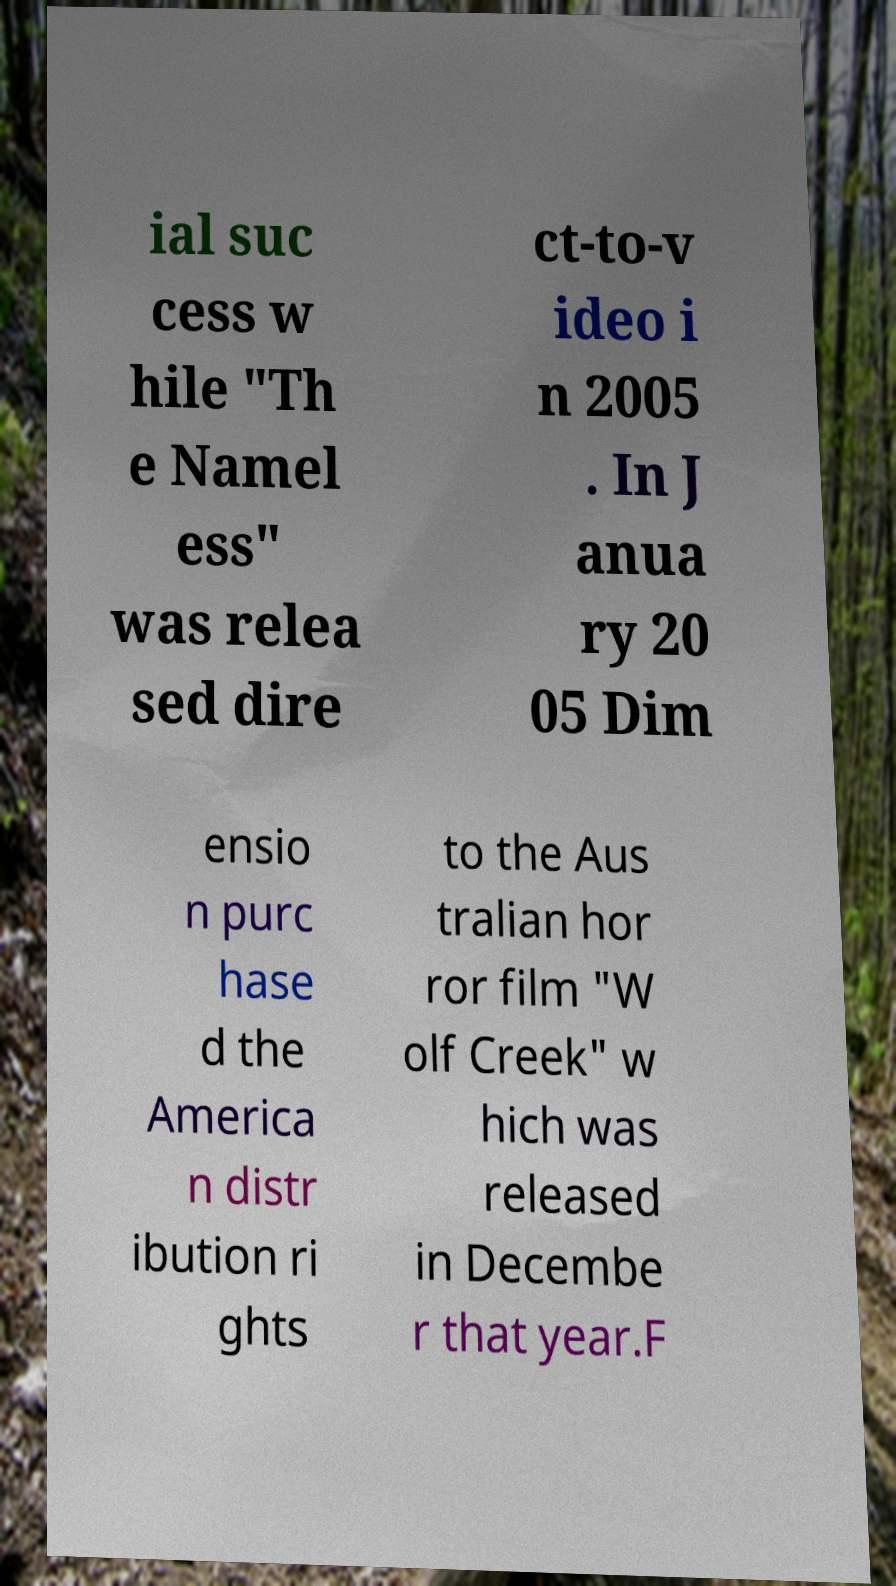What messages or text are displayed in this image? I need them in a readable, typed format. ial suc cess w hile "Th e Namel ess" was relea sed dire ct-to-v ideo i n 2005 . In J anua ry 20 05 Dim ensio n purc hase d the America n distr ibution ri ghts to the Aus tralian hor ror film "W olf Creek" w hich was released in Decembe r that year.F 